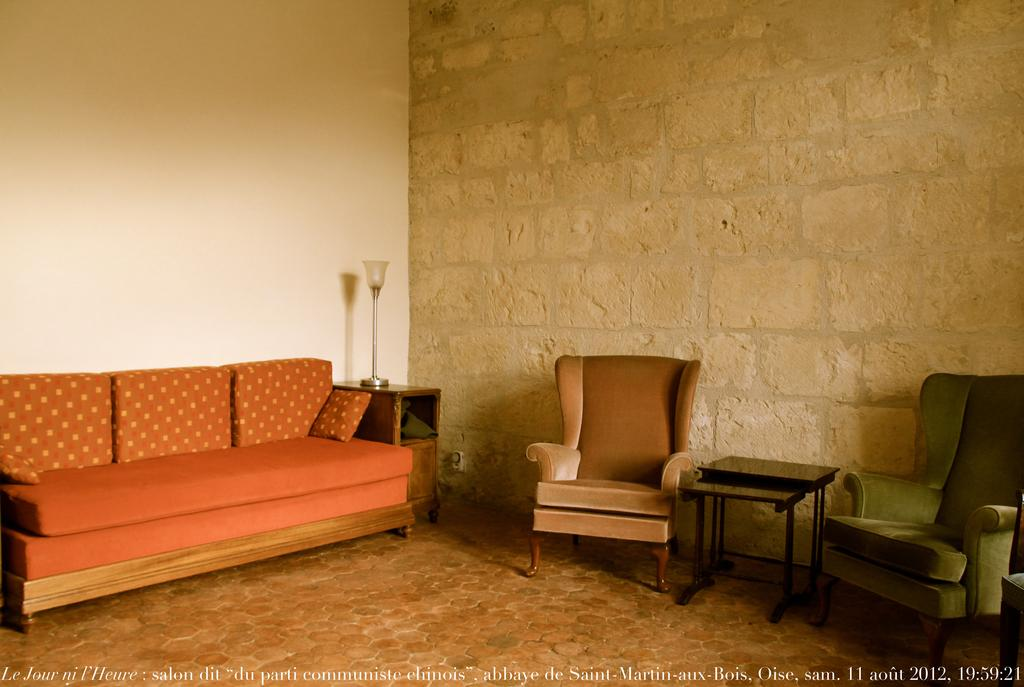What type of furniture is present in the image? There is a couch, two chairs, and a table in the image. What can be seen in the background of the image? There is a wall visible in the background of the image. What type of lighting is present in the image? There is a lamp in the image. What type of substance is being used to write on the wall in the image? There is no substance being used to write on the wall in the image. How much debt is visible on the table in the image? There is no debt present in the image; it is a room with furniture and a wall. 